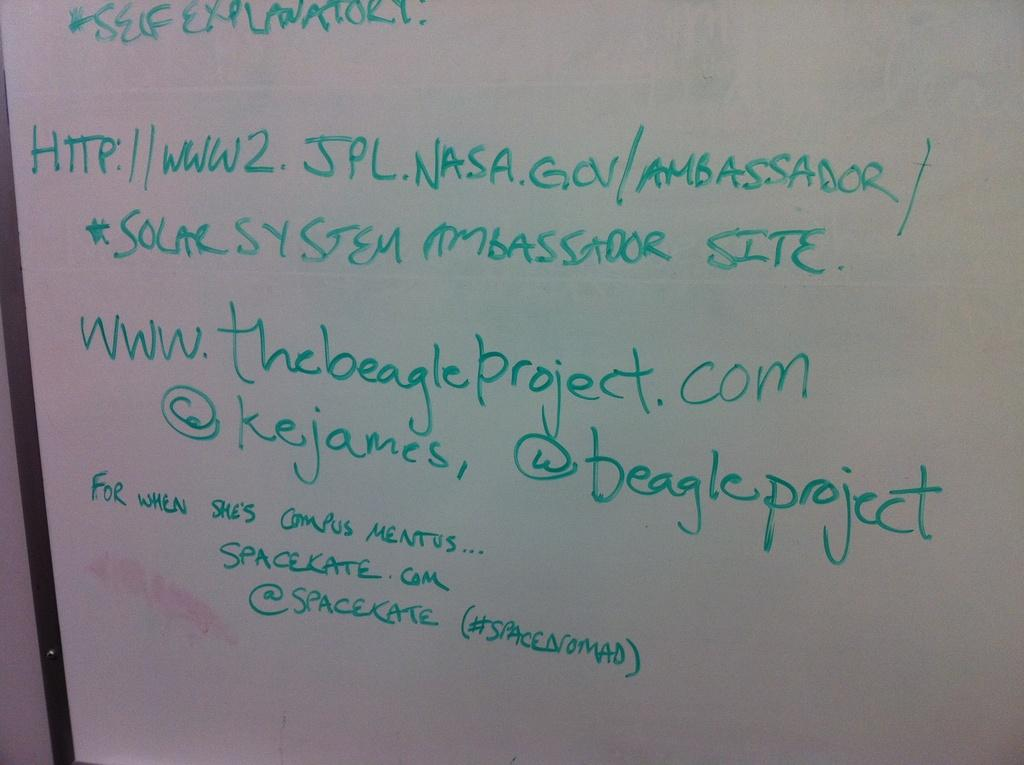<image>
Render a clear and concise summary of the photo. A white board lists some websites including one "for when she's campus mentus...spacekate.com. 